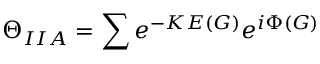<formula> <loc_0><loc_0><loc_500><loc_500>\Theta _ { I I A } = \sum e ^ { - K E ( G ) } e ^ { i \Phi ( G ) }</formula> 